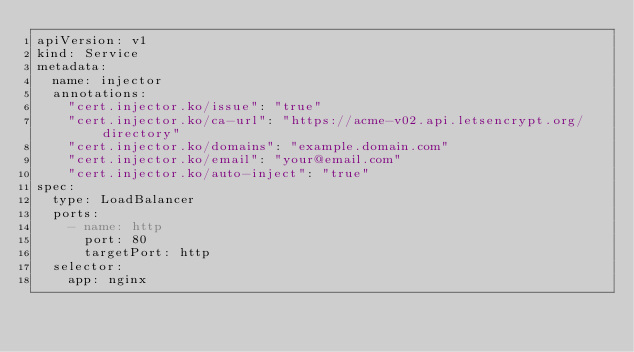Convert code to text. <code><loc_0><loc_0><loc_500><loc_500><_YAML_>apiVersion: v1
kind: Service
metadata:
  name: injector
  annotations:
    "cert.injector.ko/issue": "true"
    "cert.injector.ko/ca-url": "https://acme-v02.api.letsencrypt.org/directory"
    "cert.injector.ko/domains": "example.domain.com"
    "cert.injector.ko/email": "your@email.com"
    "cert.injector.ko/auto-inject": "true"
spec:
  type: LoadBalancer
  ports:
    - name: http
      port: 80
      targetPort: http
  selector:
    app: nginx</code> 